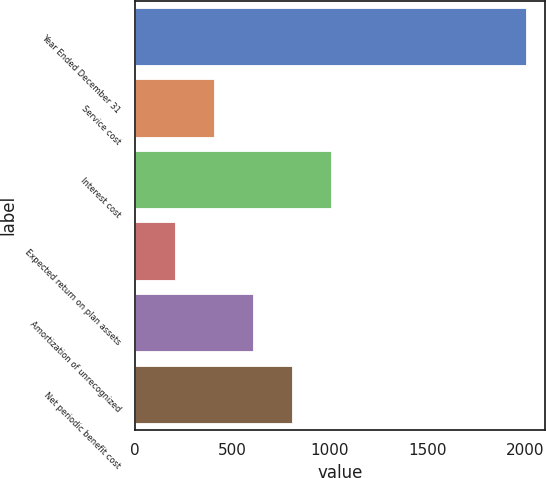<chart> <loc_0><loc_0><loc_500><loc_500><bar_chart><fcel>Year Ended December 31<fcel>Service cost<fcel>Interest cost<fcel>Expected return on plan assets<fcel>Amortization of unrecognized<fcel>Net periodic benefit cost<nl><fcel>2004<fcel>402.48<fcel>1003.05<fcel>202.29<fcel>602.67<fcel>802.86<nl></chart> 